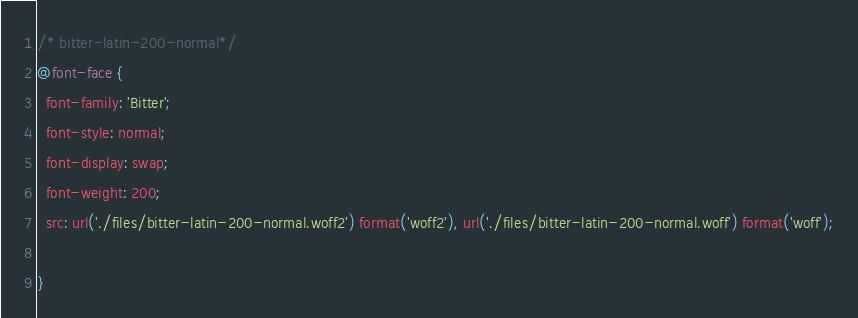Convert code to text. <code><loc_0><loc_0><loc_500><loc_500><_CSS_>/* bitter-latin-200-normal*/
@font-face {
  font-family: 'Bitter';
  font-style: normal;
  font-display: swap;
  font-weight: 200;
  src: url('./files/bitter-latin-200-normal.woff2') format('woff2'), url('./files/bitter-latin-200-normal.woff') format('woff');
  
}
</code> 